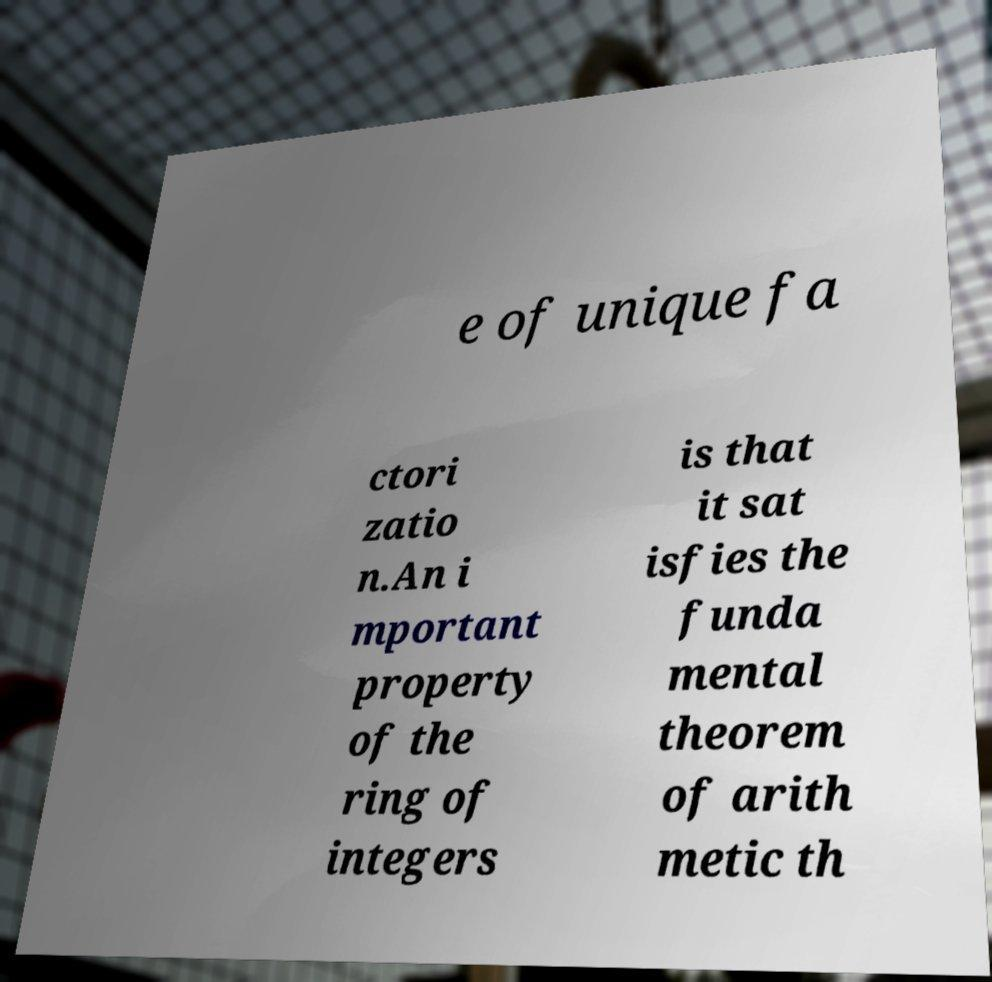For documentation purposes, I need the text within this image transcribed. Could you provide that? e of unique fa ctori zatio n.An i mportant property of the ring of integers is that it sat isfies the funda mental theorem of arith metic th 